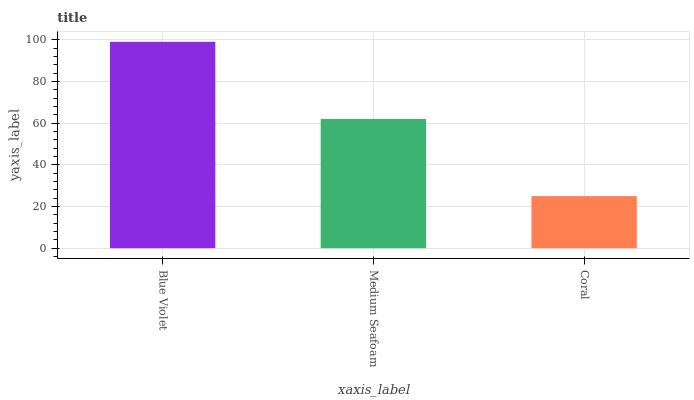Is Coral the minimum?
Answer yes or no. Yes. Is Blue Violet the maximum?
Answer yes or no. Yes. Is Medium Seafoam the minimum?
Answer yes or no. No. Is Medium Seafoam the maximum?
Answer yes or no. No. Is Blue Violet greater than Medium Seafoam?
Answer yes or no. Yes. Is Medium Seafoam less than Blue Violet?
Answer yes or no. Yes. Is Medium Seafoam greater than Blue Violet?
Answer yes or no. No. Is Blue Violet less than Medium Seafoam?
Answer yes or no. No. Is Medium Seafoam the high median?
Answer yes or no. Yes. Is Medium Seafoam the low median?
Answer yes or no. Yes. Is Coral the high median?
Answer yes or no. No. Is Coral the low median?
Answer yes or no. No. 